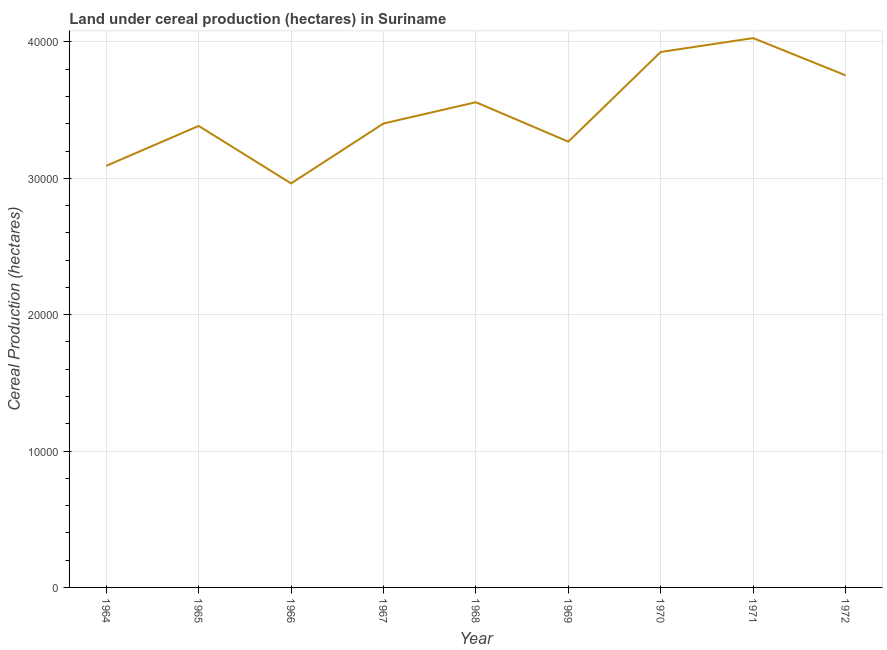What is the land under cereal production in 1964?
Provide a short and direct response. 3.09e+04. Across all years, what is the maximum land under cereal production?
Your answer should be very brief. 4.03e+04. Across all years, what is the minimum land under cereal production?
Provide a short and direct response. 2.96e+04. In which year was the land under cereal production maximum?
Your answer should be compact. 1971. In which year was the land under cereal production minimum?
Keep it short and to the point. 1966. What is the sum of the land under cereal production?
Offer a terse response. 3.14e+05. What is the difference between the land under cereal production in 1967 and 1969?
Your answer should be very brief. 1330. What is the average land under cereal production per year?
Ensure brevity in your answer.  3.49e+04. What is the median land under cereal production?
Your answer should be compact. 3.40e+04. In how many years, is the land under cereal production greater than 8000 hectares?
Offer a terse response. 9. What is the ratio of the land under cereal production in 1964 to that in 1967?
Keep it short and to the point. 0.91. Is the land under cereal production in 1965 less than that in 1969?
Make the answer very short. No. What is the difference between the highest and the second highest land under cereal production?
Ensure brevity in your answer.  1018. Is the sum of the land under cereal production in 1965 and 1968 greater than the maximum land under cereal production across all years?
Keep it short and to the point. Yes. What is the difference between the highest and the lowest land under cereal production?
Keep it short and to the point. 1.07e+04. Does the land under cereal production monotonically increase over the years?
Provide a short and direct response. No. How many lines are there?
Keep it short and to the point. 1. How many years are there in the graph?
Keep it short and to the point. 9. Are the values on the major ticks of Y-axis written in scientific E-notation?
Keep it short and to the point. No. Does the graph contain any zero values?
Offer a terse response. No. What is the title of the graph?
Your answer should be very brief. Land under cereal production (hectares) in Suriname. What is the label or title of the X-axis?
Your response must be concise. Year. What is the label or title of the Y-axis?
Provide a succinct answer. Cereal Production (hectares). What is the Cereal Production (hectares) in 1964?
Your answer should be compact. 3.09e+04. What is the Cereal Production (hectares) of 1965?
Provide a short and direct response. 3.38e+04. What is the Cereal Production (hectares) in 1966?
Your answer should be very brief. 2.96e+04. What is the Cereal Production (hectares) of 1967?
Your answer should be compact. 3.40e+04. What is the Cereal Production (hectares) in 1968?
Ensure brevity in your answer.  3.56e+04. What is the Cereal Production (hectares) in 1969?
Your answer should be compact. 3.27e+04. What is the Cereal Production (hectares) in 1970?
Your answer should be compact. 3.93e+04. What is the Cereal Production (hectares) in 1971?
Your answer should be compact. 4.03e+04. What is the Cereal Production (hectares) in 1972?
Your answer should be compact. 3.75e+04. What is the difference between the Cereal Production (hectares) in 1964 and 1965?
Give a very brief answer. -2925. What is the difference between the Cereal Production (hectares) in 1964 and 1966?
Offer a terse response. 1289. What is the difference between the Cereal Production (hectares) in 1964 and 1967?
Provide a short and direct response. -3103. What is the difference between the Cereal Production (hectares) in 1964 and 1968?
Provide a short and direct response. -4663. What is the difference between the Cereal Production (hectares) in 1964 and 1969?
Provide a succinct answer. -1773. What is the difference between the Cereal Production (hectares) in 1964 and 1970?
Give a very brief answer. -8348. What is the difference between the Cereal Production (hectares) in 1964 and 1971?
Provide a short and direct response. -9366. What is the difference between the Cereal Production (hectares) in 1964 and 1972?
Your response must be concise. -6636. What is the difference between the Cereal Production (hectares) in 1965 and 1966?
Your answer should be very brief. 4214. What is the difference between the Cereal Production (hectares) in 1965 and 1967?
Offer a very short reply. -178. What is the difference between the Cereal Production (hectares) in 1965 and 1968?
Provide a succinct answer. -1738. What is the difference between the Cereal Production (hectares) in 1965 and 1969?
Your answer should be very brief. 1152. What is the difference between the Cereal Production (hectares) in 1965 and 1970?
Ensure brevity in your answer.  -5423. What is the difference between the Cereal Production (hectares) in 1965 and 1971?
Offer a terse response. -6441. What is the difference between the Cereal Production (hectares) in 1965 and 1972?
Ensure brevity in your answer.  -3711. What is the difference between the Cereal Production (hectares) in 1966 and 1967?
Make the answer very short. -4392. What is the difference between the Cereal Production (hectares) in 1966 and 1968?
Your answer should be compact. -5952. What is the difference between the Cereal Production (hectares) in 1966 and 1969?
Your response must be concise. -3062. What is the difference between the Cereal Production (hectares) in 1966 and 1970?
Your response must be concise. -9637. What is the difference between the Cereal Production (hectares) in 1966 and 1971?
Your response must be concise. -1.07e+04. What is the difference between the Cereal Production (hectares) in 1966 and 1972?
Provide a short and direct response. -7925. What is the difference between the Cereal Production (hectares) in 1967 and 1968?
Ensure brevity in your answer.  -1560. What is the difference between the Cereal Production (hectares) in 1967 and 1969?
Offer a terse response. 1330. What is the difference between the Cereal Production (hectares) in 1967 and 1970?
Your answer should be compact. -5245. What is the difference between the Cereal Production (hectares) in 1967 and 1971?
Make the answer very short. -6263. What is the difference between the Cereal Production (hectares) in 1967 and 1972?
Give a very brief answer. -3533. What is the difference between the Cereal Production (hectares) in 1968 and 1969?
Make the answer very short. 2890. What is the difference between the Cereal Production (hectares) in 1968 and 1970?
Your answer should be compact. -3685. What is the difference between the Cereal Production (hectares) in 1968 and 1971?
Give a very brief answer. -4703. What is the difference between the Cereal Production (hectares) in 1968 and 1972?
Offer a very short reply. -1973. What is the difference between the Cereal Production (hectares) in 1969 and 1970?
Provide a short and direct response. -6575. What is the difference between the Cereal Production (hectares) in 1969 and 1971?
Provide a short and direct response. -7593. What is the difference between the Cereal Production (hectares) in 1969 and 1972?
Offer a terse response. -4863. What is the difference between the Cereal Production (hectares) in 1970 and 1971?
Offer a terse response. -1018. What is the difference between the Cereal Production (hectares) in 1970 and 1972?
Your answer should be compact. 1712. What is the difference between the Cereal Production (hectares) in 1971 and 1972?
Keep it short and to the point. 2730. What is the ratio of the Cereal Production (hectares) in 1964 to that in 1965?
Provide a succinct answer. 0.91. What is the ratio of the Cereal Production (hectares) in 1964 to that in 1966?
Offer a terse response. 1.04. What is the ratio of the Cereal Production (hectares) in 1964 to that in 1967?
Your answer should be very brief. 0.91. What is the ratio of the Cereal Production (hectares) in 1964 to that in 1968?
Ensure brevity in your answer.  0.87. What is the ratio of the Cereal Production (hectares) in 1964 to that in 1969?
Offer a very short reply. 0.95. What is the ratio of the Cereal Production (hectares) in 1964 to that in 1970?
Give a very brief answer. 0.79. What is the ratio of the Cereal Production (hectares) in 1964 to that in 1971?
Make the answer very short. 0.77. What is the ratio of the Cereal Production (hectares) in 1964 to that in 1972?
Keep it short and to the point. 0.82. What is the ratio of the Cereal Production (hectares) in 1965 to that in 1966?
Keep it short and to the point. 1.14. What is the ratio of the Cereal Production (hectares) in 1965 to that in 1968?
Offer a terse response. 0.95. What is the ratio of the Cereal Production (hectares) in 1965 to that in 1969?
Ensure brevity in your answer.  1.03. What is the ratio of the Cereal Production (hectares) in 1965 to that in 1970?
Offer a terse response. 0.86. What is the ratio of the Cereal Production (hectares) in 1965 to that in 1971?
Give a very brief answer. 0.84. What is the ratio of the Cereal Production (hectares) in 1965 to that in 1972?
Ensure brevity in your answer.  0.9. What is the ratio of the Cereal Production (hectares) in 1966 to that in 1967?
Offer a very short reply. 0.87. What is the ratio of the Cereal Production (hectares) in 1966 to that in 1968?
Give a very brief answer. 0.83. What is the ratio of the Cereal Production (hectares) in 1966 to that in 1969?
Ensure brevity in your answer.  0.91. What is the ratio of the Cereal Production (hectares) in 1966 to that in 1970?
Your response must be concise. 0.76. What is the ratio of the Cereal Production (hectares) in 1966 to that in 1971?
Your answer should be compact. 0.73. What is the ratio of the Cereal Production (hectares) in 1966 to that in 1972?
Your response must be concise. 0.79. What is the ratio of the Cereal Production (hectares) in 1967 to that in 1968?
Give a very brief answer. 0.96. What is the ratio of the Cereal Production (hectares) in 1967 to that in 1969?
Make the answer very short. 1.04. What is the ratio of the Cereal Production (hectares) in 1967 to that in 1970?
Keep it short and to the point. 0.87. What is the ratio of the Cereal Production (hectares) in 1967 to that in 1971?
Provide a succinct answer. 0.84. What is the ratio of the Cereal Production (hectares) in 1967 to that in 1972?
Provide a succinct answer. 0.91. What is the ratio of the Cereal Production (hectares) in 1968 to that in 1969?
Ensure brevity in your answer.  1.09. What is the ratio of the Cereal Production (hectares) in 1968 to that in 1970?
Offer a very short reply. 0.91. What is the ratio of the Cereal Production (hectares) in 1968 to that in 1971?
Provide a succinct answer. 0.88. What is the ratio of the Cereal Production (hectares) in 1968 to that in 1972?
Make the answer very short. 0.95. What is the ratio of the Cereal Production (hectares) in 1969 to that in 1970?
Offer a very short reply. 0.83. What is the ratio of the Cereal Production (hectares) in 1969 to that in 1971?
Your answer should be very brief. 0.81. What is the ratio of the Cereal Production (hectares) in 1969 to that in 1972?
Your answer should be very brief. 0.87. What is the ratio of the Cereal Production (hectares) in 1970 to that in 1972?
Keep it short and to the point. 1.05. What is the ratio of the Cereal Production (hectares) in 1971 to that in 1972?
Provide a succinct answer. 1.07. 